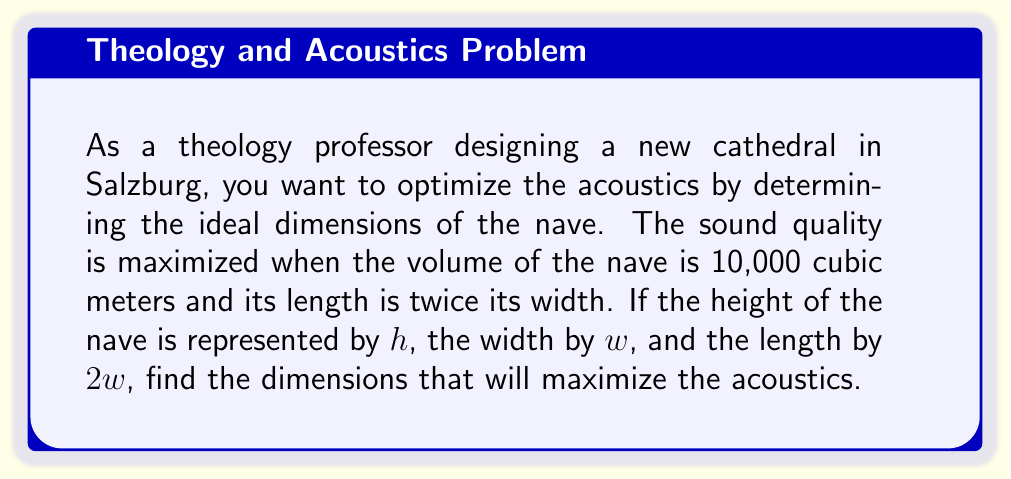Help me with this question. Let's approach this step-by-step:

1) We know that the volume of the nave is 10,000 cubic meters. We can express this as:

   $V = l * w * h = 10,000$

2) We're told that the length is twice the width, so $l = 2w$. Substituting this into our volume equation:

   $(2w) * w * h = 10,000$

3) Simplifying:

   $2w^2h = 10,000$

4) Now, we want to express $h$ in terms of $w$:

   $h = \frac{10,000}{2w^2} = \frac{5,000}{w^2}$

5) To find the optimal dimensions, we need to find the minimum value of $w$ that satisfies this equation. We can do this by taking the derivative of $h$ with respect to $w$ and setting it equal to zero:

   $\frac{dh}{dw} = -\frac{10,000}{w^3}$

6) Setting this equal to zero:

   $-\frac{10,000}{w^3} = 0$

7) This is true when $w$ approaches infinity, which isn't practical. Instead, we need to consider the constraints of our problem. We know that $h * w * 2w = 10,000$, so:

   $\frac{5,000}{w^2} * w * 2w = 10,000$

8) Simplifying:

   $10,000 = 10,000$

9) This shows that our equation is correct for all values of $w$. To find the specific dimensions, we can choose a value for $w$ that gives reasonable proportions. A common ratio in cathedral architecture is to have the height equal to the width. So, let's set $h = w$:

   $w = \frac{5,000}{w^2}$

10) Solving this:

    $w^3 = 5,000$
    $w = \sqrt[3]{5,000} \approx 17.1$ meters

11) Now we can calculate the other dimensions:

    $h = w \approx 17.1$ meters
    $l = 2w \approx 34.2$ meters
Answer: Width ≈ 17.1 m, Length ≈ 34.2 m, Height ≈ 17.1 m 